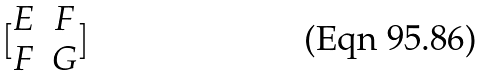Convert formula to latex. <formula><loc_0><loc_0><loc_500><loc_500>[ \begin{matrix} E & F \\ F & G \end{matrix} ]</formula> 